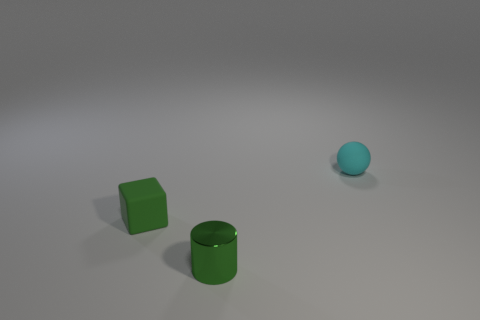Add 1 cyan rubber balls. How many objects exist? 4 Subtract all spheres. How many objects are left? 2 Add 3 cyan rubber objects. How many cyan rubber objects are left? 4 Add 2 brown metallic blocks. How many brown metallic blocks exist? 2 Subtract 0 gray cubes. How many objects are left? 3 Subtract all tiny things. Subtract all red metallic things. How many objects are left? 0 